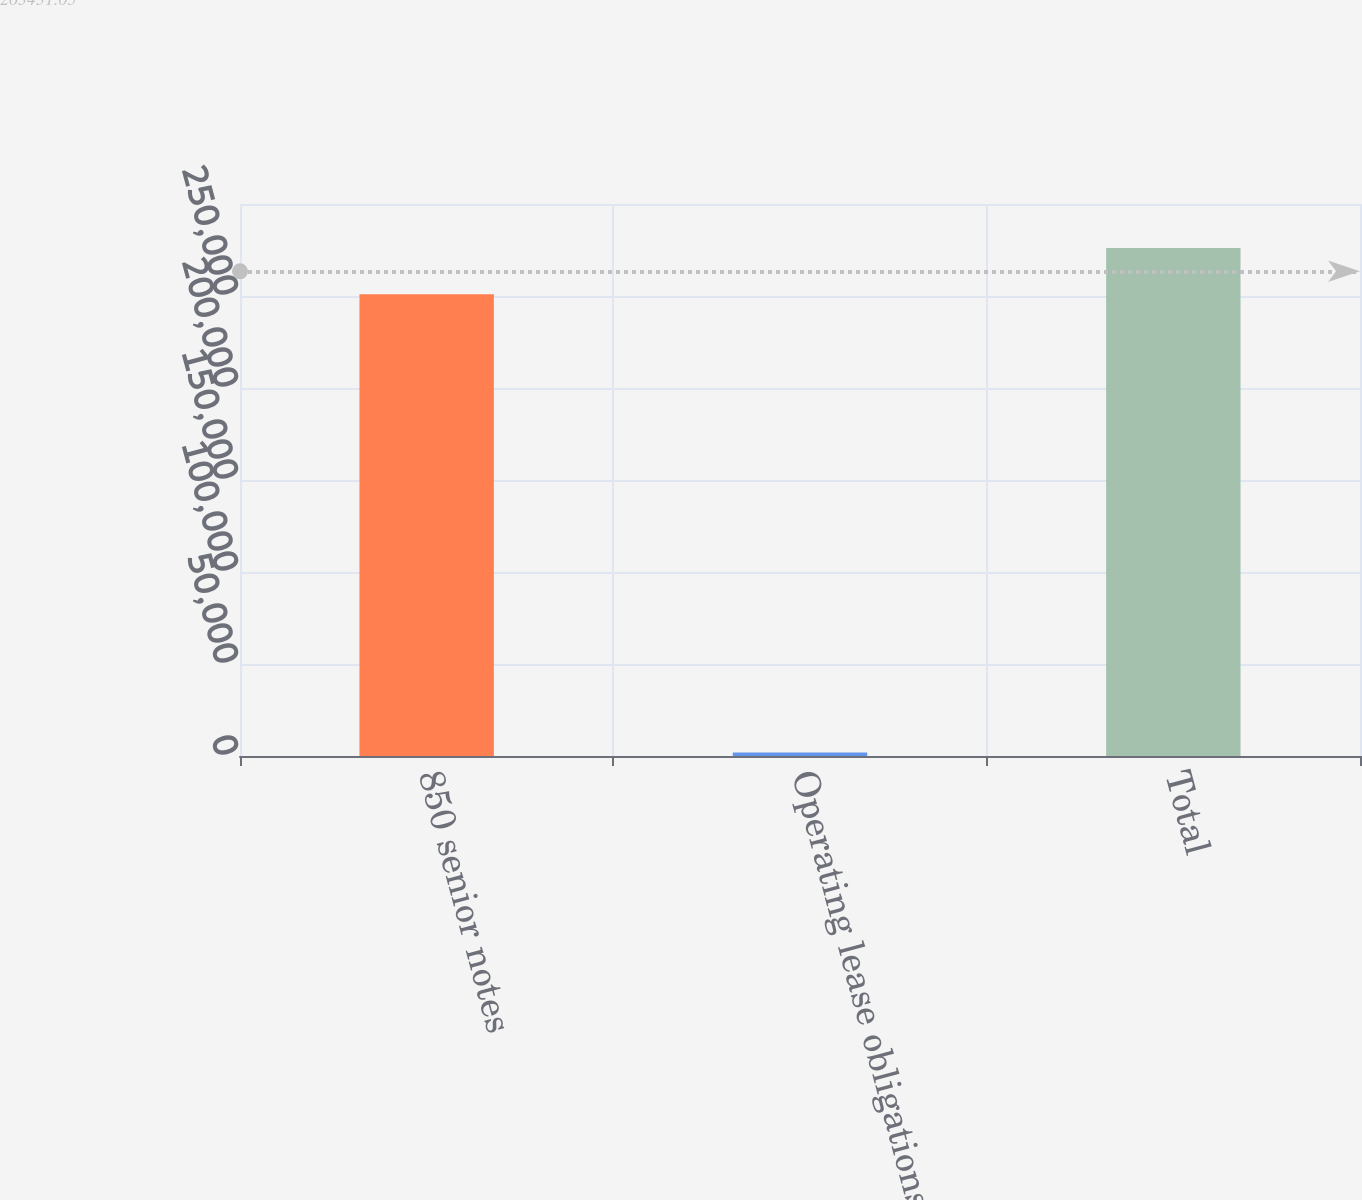Convert chart. <chart><loc_0><loc_0><loc_500><loc_500><bar_chart><fcel>850 senior notes<fcel>Operating lease obligations<fcel>Total<nl><fcel>251000<fcel>1868<fcel>276100<nl></chart> 